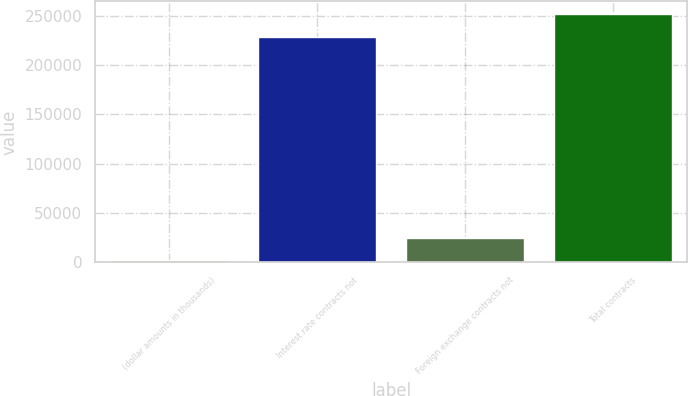Convert chart. <chart><loc_0><loc_0><loc_500><loc_500><bar_chart><fcel>(dollar amounts in thousands)<fcel>Interest rate contracts not<fcel>Foreign exchange contracts not<fcel>Total contracts<nl><fcel>2012<fcel>228757<fcel>25152<fcel>251897<nl></chart> 